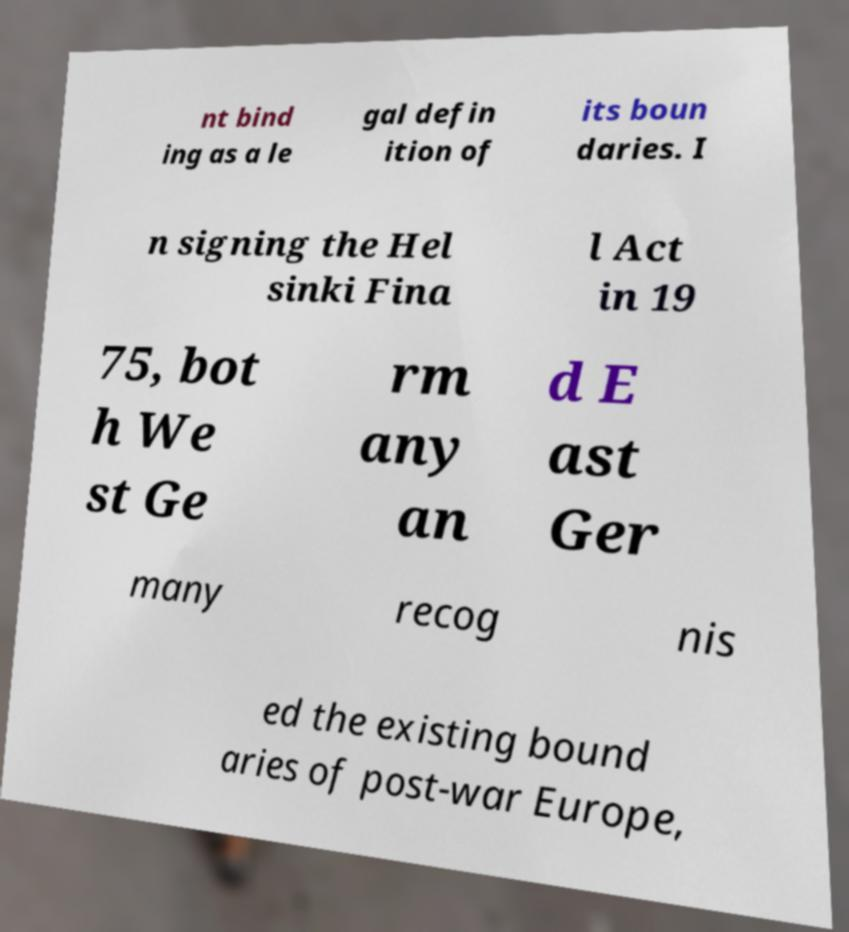Can you accurately transcribe the text from the provided image for me? nt bind ing as a le gal defin ition of its boun daries. I n signing the Hel sinki Fina l Act in 19 75, bot h We st Ge rm any an d E ast Ger many recog nis ed the existing bound aries of post-war Europe, 